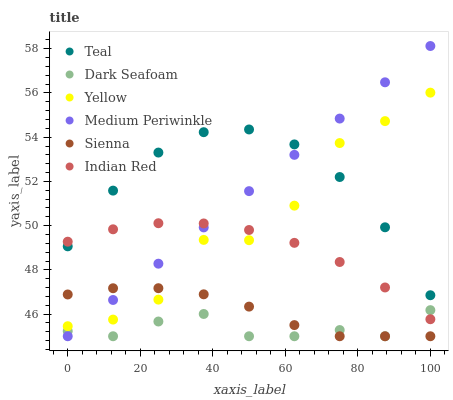Does Dark Seafoam have the minimum area under the curve?
Answer yes or no. Yes. Does Teal have the maximum area under the curve?
Answer yes or no. Yes. Does Medium Periwinkle have the minimum area under the curve?
Answer yes or no. No. Does Medium Periwinkle have the maximum area under the curve?
Answer yes or no. No. Is Medium Periwinkle the smoothest?
Answer yes or no. Yes. Is Yellow the roughest?
Answer yes or no. Yes. Is Yellow the smoothest?
Answer yes or no. No. Is Medium Periwinkle the roughest?
Answer yes or no. No. Does Medium Periwinkle have the lowest value?
Answer yes or no. Yes. Does Yellow have the lowest value?
Answer yes or no. No. Does Medium Periwinkle have the highest value?
Answer yes or no. Yes. Does Yellow have the highest value?
Answer yes or no. No. Is Sienna less than Indian Red?
Answer yes or no. Yes. Is Yellow greater than Dark Seafoam?
Answer yes or no. Yes. Does Medium Periwinkle intersect Dark Seafoam?
Answer yes or no. Yes. Is Medium Periwinkle less than Dark Seafoam?
Answer yes or no. No. Is Medium Periwinkle greater than Dark Seafoam?
Answer yes or no. No. Does Sienna intersect Indian Red?
Answer yes or no. No. 